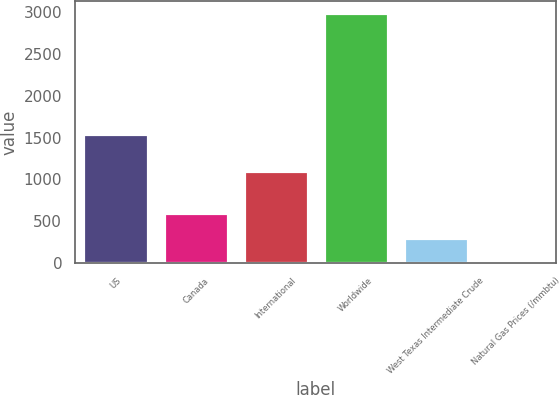Convert chart. <chart><loc_0><loc_0><loc_500><loc_500><bar_chart><fcel>US<fcel>Canada<fcel>International<fcel>Worldwide<fcel>West Texas Intermediate Crude<fcel>Natural Gas Prices (/mmbtu)<nl><fcel>1541<fcel>600.71<fcel>1094<fcel>2986<fcel>302.55<fcel>4.39<nl></chart> 